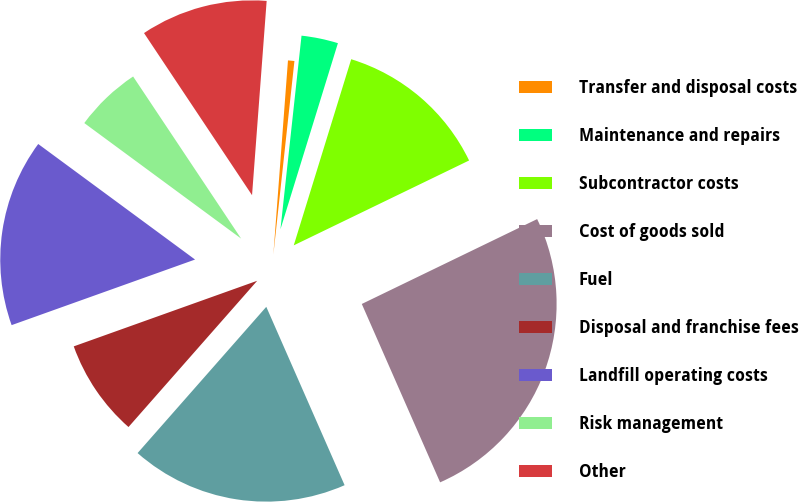Convert chart to OTSL. <chart><loc_0><loc_0><loc_500><loc_500><pie_chart><fcel>Transfer and disposal costs<fcel>Maintenance and repairs<fcel>Subcontractor costs<fcel>Cost of goods sold<fcel>Fuel<fcel>Disposal and franchise fees<fcel>Landfill operating costs<fcel>Risk management<fcel>Other<nl><fcel>0.53%<fcel>3.04%<fcel>13.06%<fcel>25.59%<fcel>18.07%<fcel>8.05%<fcel>15.57%<fcel>5.54%<fcel>10.55%<nl></chart> 